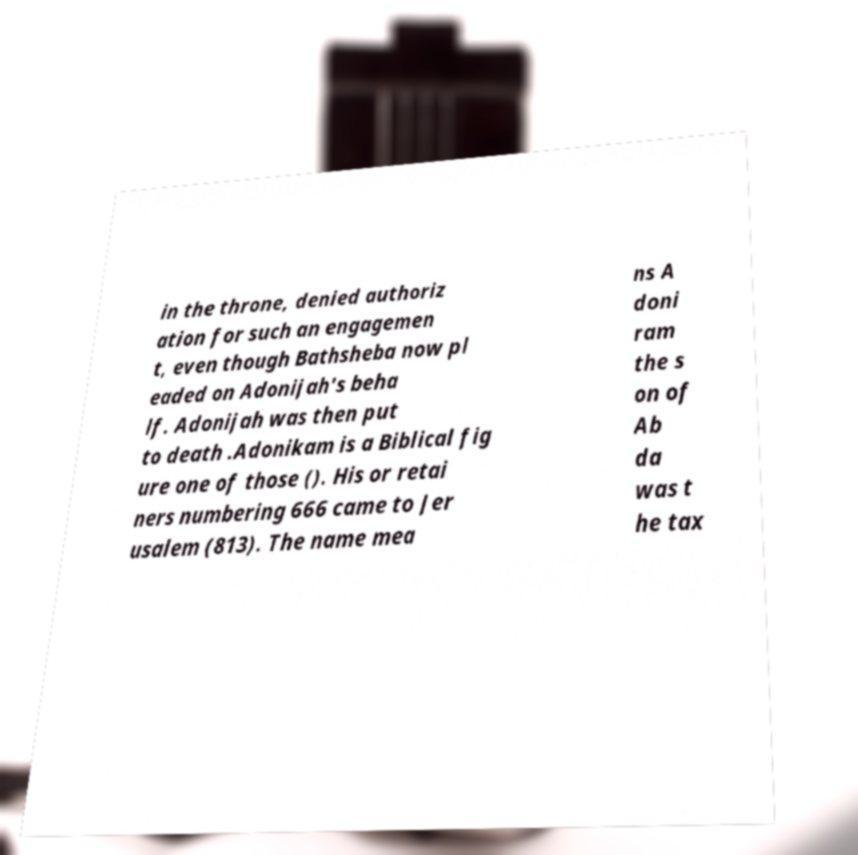Can you accurately transcribe the text from the provided image for me? in the throne, denied authoriz ation for such an engagemen t, even though Bathsheba now pl eaded on Adonijah's beha lf. Adonijah was then put to death .Adonikam is a Biblical fig ure one of those (). His or retai ners numbering 666 came to Jer usalem (813). The name mea ns A doni ram the s on of Ab da was t he tax 